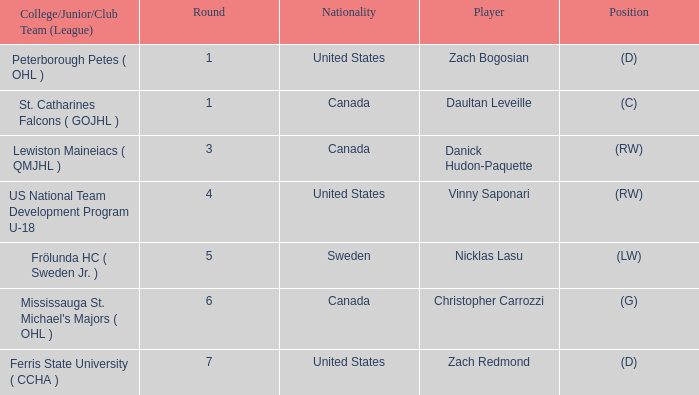What is the Player in Round 5? Nicklas Lasu. 